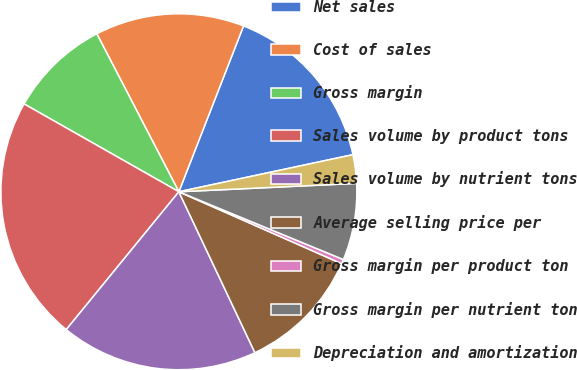<chart> <loc_0><loc_0><loc_500><loc_500><pie_chart><fcel>Net sales<fcel>Cost of sales<fcel>Gross margin<fcel>Sales volume by product tons<fcel>Sales volume by nutrient tons<fcel>Average selling price per<fcel>Gross margin per product ton<fcel>Gross margin per nutrient ton<fcel>Depreciation and amortization<nl><fcel>15.74%<fcel>13.54%<fcel>9.16%<fcel>22.31%<fcel>17.93%<fcel>11.35%<fcel>0.4%<fcel>6.97%<fcel>2.59%<nl></chart> 